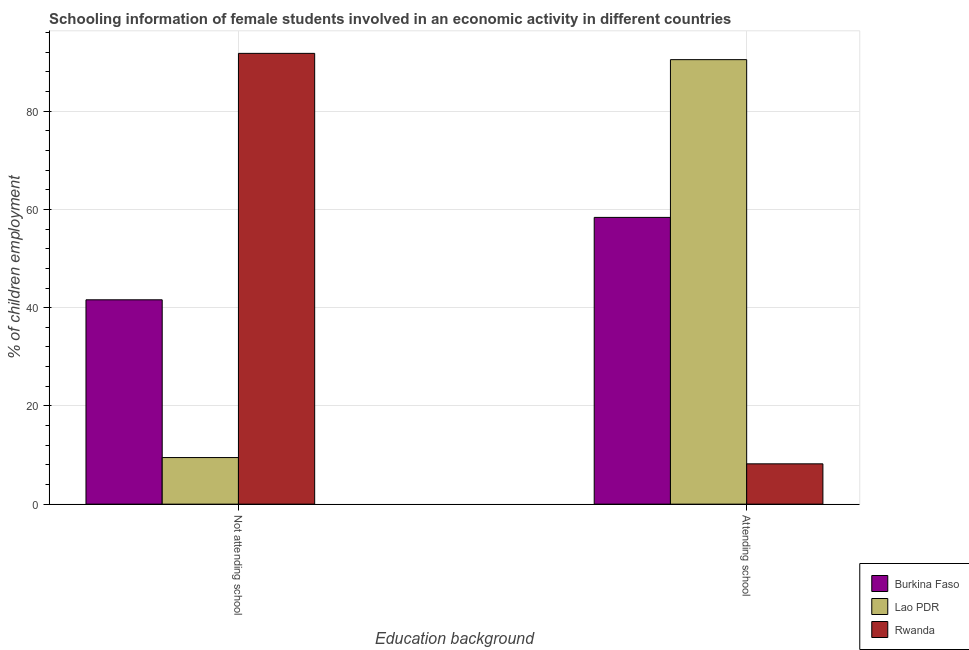Are the number of bars per tick equal to the number of legend labels?
Provide a short and direct response. Yes. Are the number of bars on each tick of the X-axis equal?
Provide a short and direct response. Yes. How many bars are there on the 2nd tick from the left?
Your answer should be compact. 3. What is the label of the 1st group of bars from the left?
Provide a succinct answer. Not attending school. What is the percentage of employed females who are attending school in Burkina Faso?
Ensure brevity in your answer.  58.39. Across all countries, what is the maximum percentage of employed females who are attending school?
Your answer should be compact. 90.51. Across all countries, what is the minimum percentage of employed females who are not attending school?
Ensure brevity in your answer.  9.49. In which country was the percentage of employed females who are attending school maximum?
Your answer should be compact. Lao PDR. In which country was the percentage of employed females who are not attending school minimum?
Offer a very short reply. Lao PDR. What is the total percentage of employed females who are not attending school in the graph?
Provide a succinct answer. 142.89. What is the difference between the percentage of employed females who are attending school in Rwanda and that in Burkina Faso?
Ensure brevity in your answer.  -50.18. What is the difference between the percentage of employed females who are attending school in Rwanda and the percentage of employed females who are not attending school in Burkina Faso?
Keep it short and to the point. -33.4. What is the average percentage of employed females who are attending school per country?
Your answer should be very brief. 52.37. What is the difference between the percentage of employed females who are not attending school and percentage of employed females who are attending school in Rwanda?
Your response must be concise. 83.58. In how many countries, is the percentage of employed females who are not attending school greater than 60 %?
Offer a very short reply. 1. What is the ratio of the percentage of employed females who are not attending school in Rwanda to that in Burkina Faso?
Offer a very short reply. 2.21. Is the percentage of employed females who are not attending school in Lao PDR less than that in Burkina Faso?
Give a very brief answer. Yes. What does the 3rd bar from the left in Attending school represents?
Your response must be concise. Rwanda. What does the 1st bar from the right in Not attending school represents?
Provide a short and direct response. Rwanda. How many bars are there?
Your response must be concise. 6. Are the values on the major ticks of Y-axis written in scientific E-notation?
Offer a terse response. No. How are the legend labels stacked?
Keep it short and to the point. Vertical. What is the title of the graph?
Your response must be concise. Schooling information of female students involved in an economic activity in different countries. Does "France" appear as one of the legend labels in the graph?
Your response must be concise. No. What is the label or title of the X-axis?
Make the answer very short. Education background. What is the label or title of the Y-axis?
Your response must be concise. % of children employment. What is the % of children employment of Burkina Faso in Not attending school?
Your answer should be very brief. 41.61. What is the % of children employment of Lao PDR in Not attending school?
Your answer should be very brief. 9.49. What is the % of children employment of Rwanda in Not attending school?
Your answer should be compact. 91.79. What is the % of children employment of Burkina Faso in Attending school?
Your answer should be very brief. 58.39. What is the % of children employment in Lao PDR in Attending school?
Your response must be concise. 90.51. What is the % of children employment in Rwanda in Attending school?
Your answer should be compact. 8.21. Across all Education background, what is the maximum % of children employment of Burkina Faso?
Provide a succinct answer. 58.39. Across all Education background, what is the maximum % of children employment in Lao PDR?
Provide a short and direct response. 90.51. Across all Education background, what is the maximum % of children employment of Rwanda?
Ensure brevity in your answer.  91.79. Across all Education background, what is the minimum % of children employment of Burkina Faso?
Ensure brevity in your answer.  41.61. Across all Education background, what is the minimum % of children employment of Lao PDR?
Your response must be concise. 9.49. Across all Education background, what is the minimum % of children employment of Rwanda?
Your response must be concise. 8.21. What is the total % of children employment in Rwanda in the graph?
Give a very brief answer. 100. What is the difference between the % of children employment of Burkina Faso in Not attending school and that in Attending school?
Offer a very short reply. -16.78. What is the difference between the % of children employment in Lao PDR in Not attending school and that in Attending school?
Provide a succinct answer. -81.02. What is the difference between the % of children employment of Rwanda in Not attending school and that in Attending school?
Offer a very short reply. 83.58. What is the difference between the % of children employment in Burkina Faso in Not attending school and the % of children employment in Lao PDR in Attending school?
Ensure brevity in your answer.  -48.9. What is the difference between the % of children employment of Burkina Faso in Not attending school and the % of children employment of Rwanda in Attending school?
Ensure brevity in your answer.  33.4. What is the difference between the % of children employment in Lao PDR in Not attending school and the % of children employment in Rwanda in Attending school?
Your response must be concise. 1.28. What is the average % of children employment of Burkina Faso per Education background?
Ensure brevity in your answer.  50. What is the difference between the % of children employment of Burkina Faso and % of children employment of Lao PDR in Not attending school?
Your answer should be compact. 32.12. What is the difference between the % of children employment of Burkina Faso and % of children employment of Rwanda in Not attending school?
Your response must be concise. -50.18. What is the difference between the % of children employment of Lao PDR and % of children employment of Rwanda in Not attending school?
Offer a very short reply. -82.3. What is the difference between the % of children employment of Burkina Faso and % of children employment of Lao PDR in Attending school?
Provide a succinct answer. -32.12. What is the difference between the % of children employment in Burkina Faso and % of children employment in Rwanda in Attending school?
Make the answer very short. 50.18. What is the difference between the % of children employment of Lao PDR and % of children employment of Rwanda in Attending school?
Give a very brief answer. 82.3. What is the ratio of the % of children employment of Burkina Faso in Not attending school to that in Attending school?
Keep it short and to the point. 0.71. What is the ratio of the % of children employment in Lao PDR in Not attending school to that in Attending school?
Give a very brief answer. 0.1. What is the ratio of the % of children employment of Rwanda in Not attending school to that in Attending school?
Your answer should be very brief. 11.18. What is the difference between the highest and the second highest % of children employment in Burkina Faso?
Make the answer very short. 16.78. What is the difference between the highest and the second highest % of children employment in Lao PDR?
Offer a very short reply. 81.02. What is the difference between the highest and the second highest % of children employment of Rwanda?
Keep it short and to the point. 83.58. What is the difference between the highest and the lowest % of children employment of Burkina Faso?
Make the answer very short. 16.78. What is the difference between the highest and the lowest % of children employment in Lao PDR?
Provide a short and direct response. 81.02. What is the difference between the highest and the lowest % of children employment of Rwanda?
Keep it short and to the point. 83.58. 